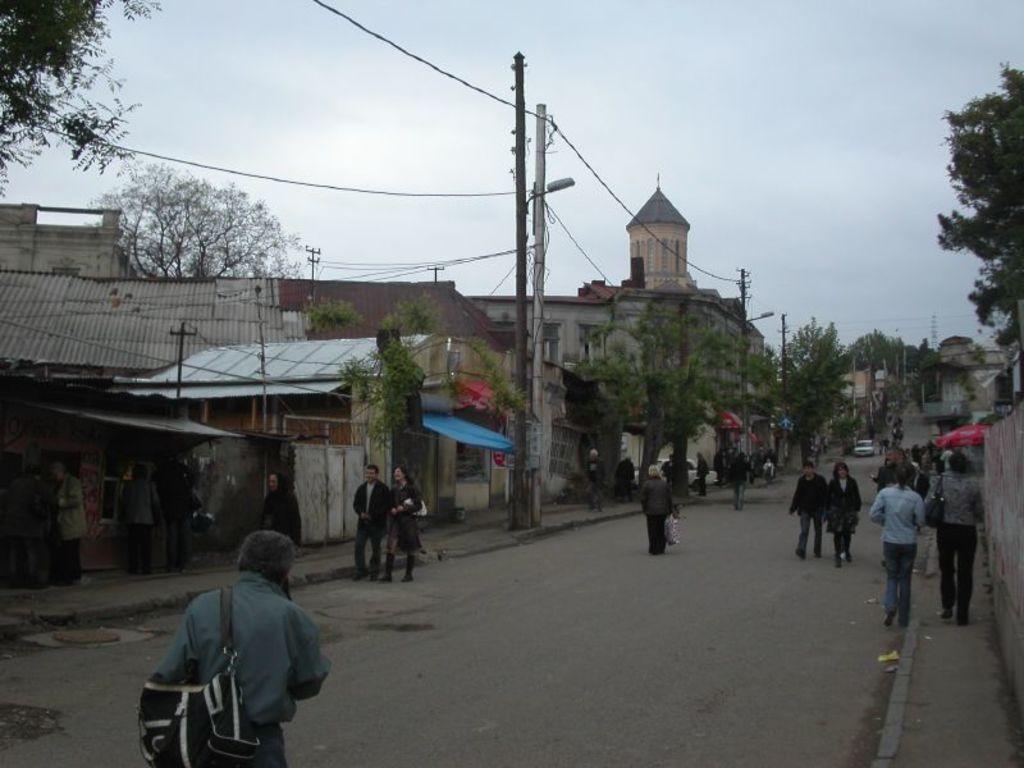Please provide a concise description of this image. In this picture I can see many people were walking on the road, beside the roads I can see electric poles, street lights and some wires are connected to the electric pole. At the top I can see the sky and clouds. 